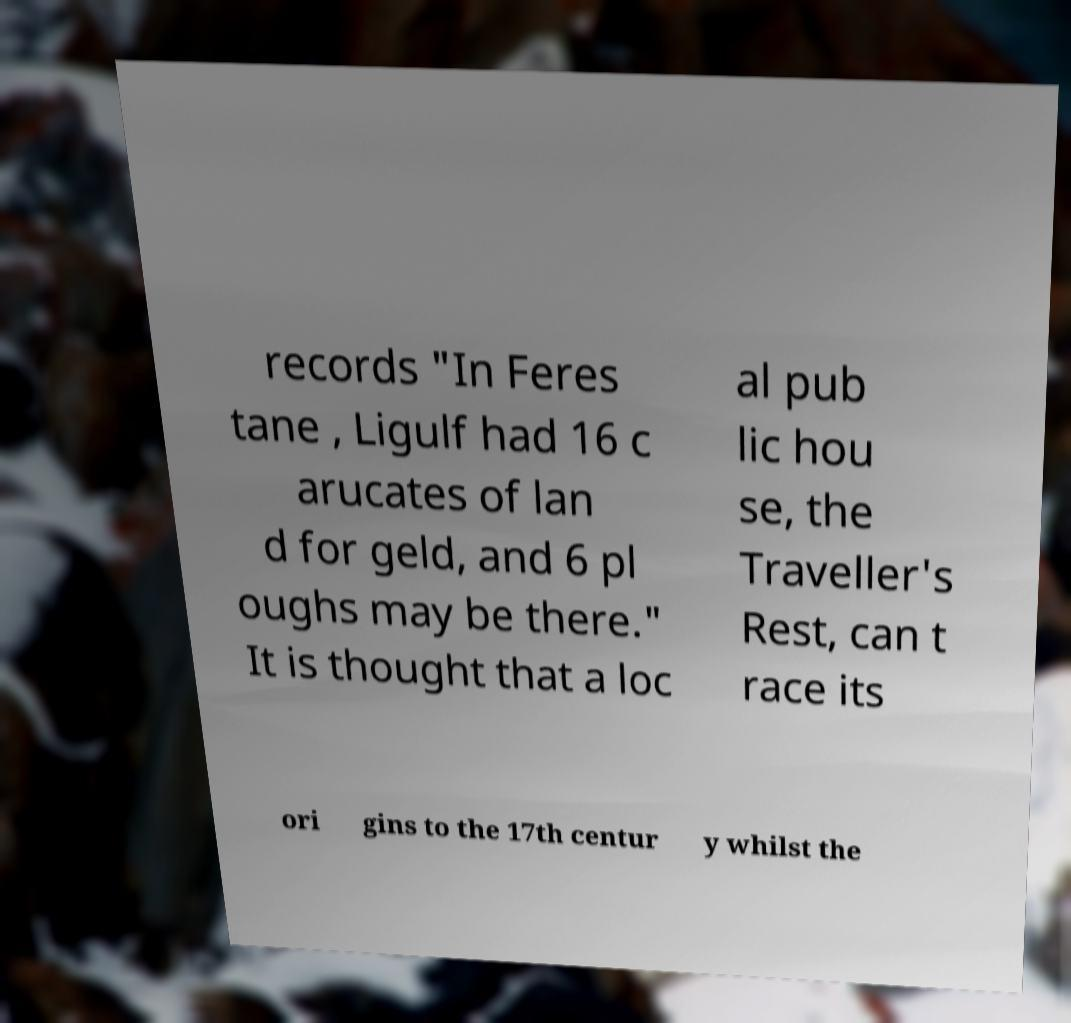Please identify and transcribe the text found in this image. records "In Feres tane , Ligulf had 16 c arucates of lan d for geld, and 6 pl oughs may be there." It is thought that a loc al pub lic hou se, the Traveller's Rest, can t race its ori gins to the 17th centur y whilst the 